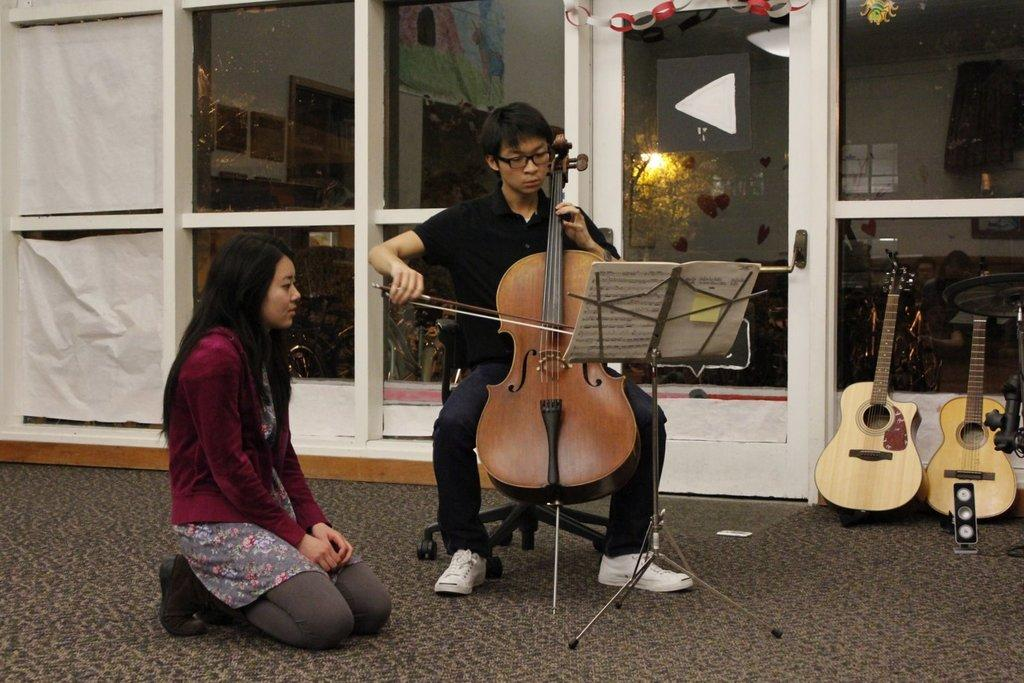What type of architectural feature is present in the image? There is a door in the image. What other features can be seen in the image? There are windows in the image. How many people are in the image? There are two people in the image. What object related to communication or documentation is present in the image? There is a paper in the image. What type of musical instruments can be seen in the image? There are guitars in the image. What type of cracker is being used to adjust the sofa in the image? There is no cracker or sofa present in the image. 